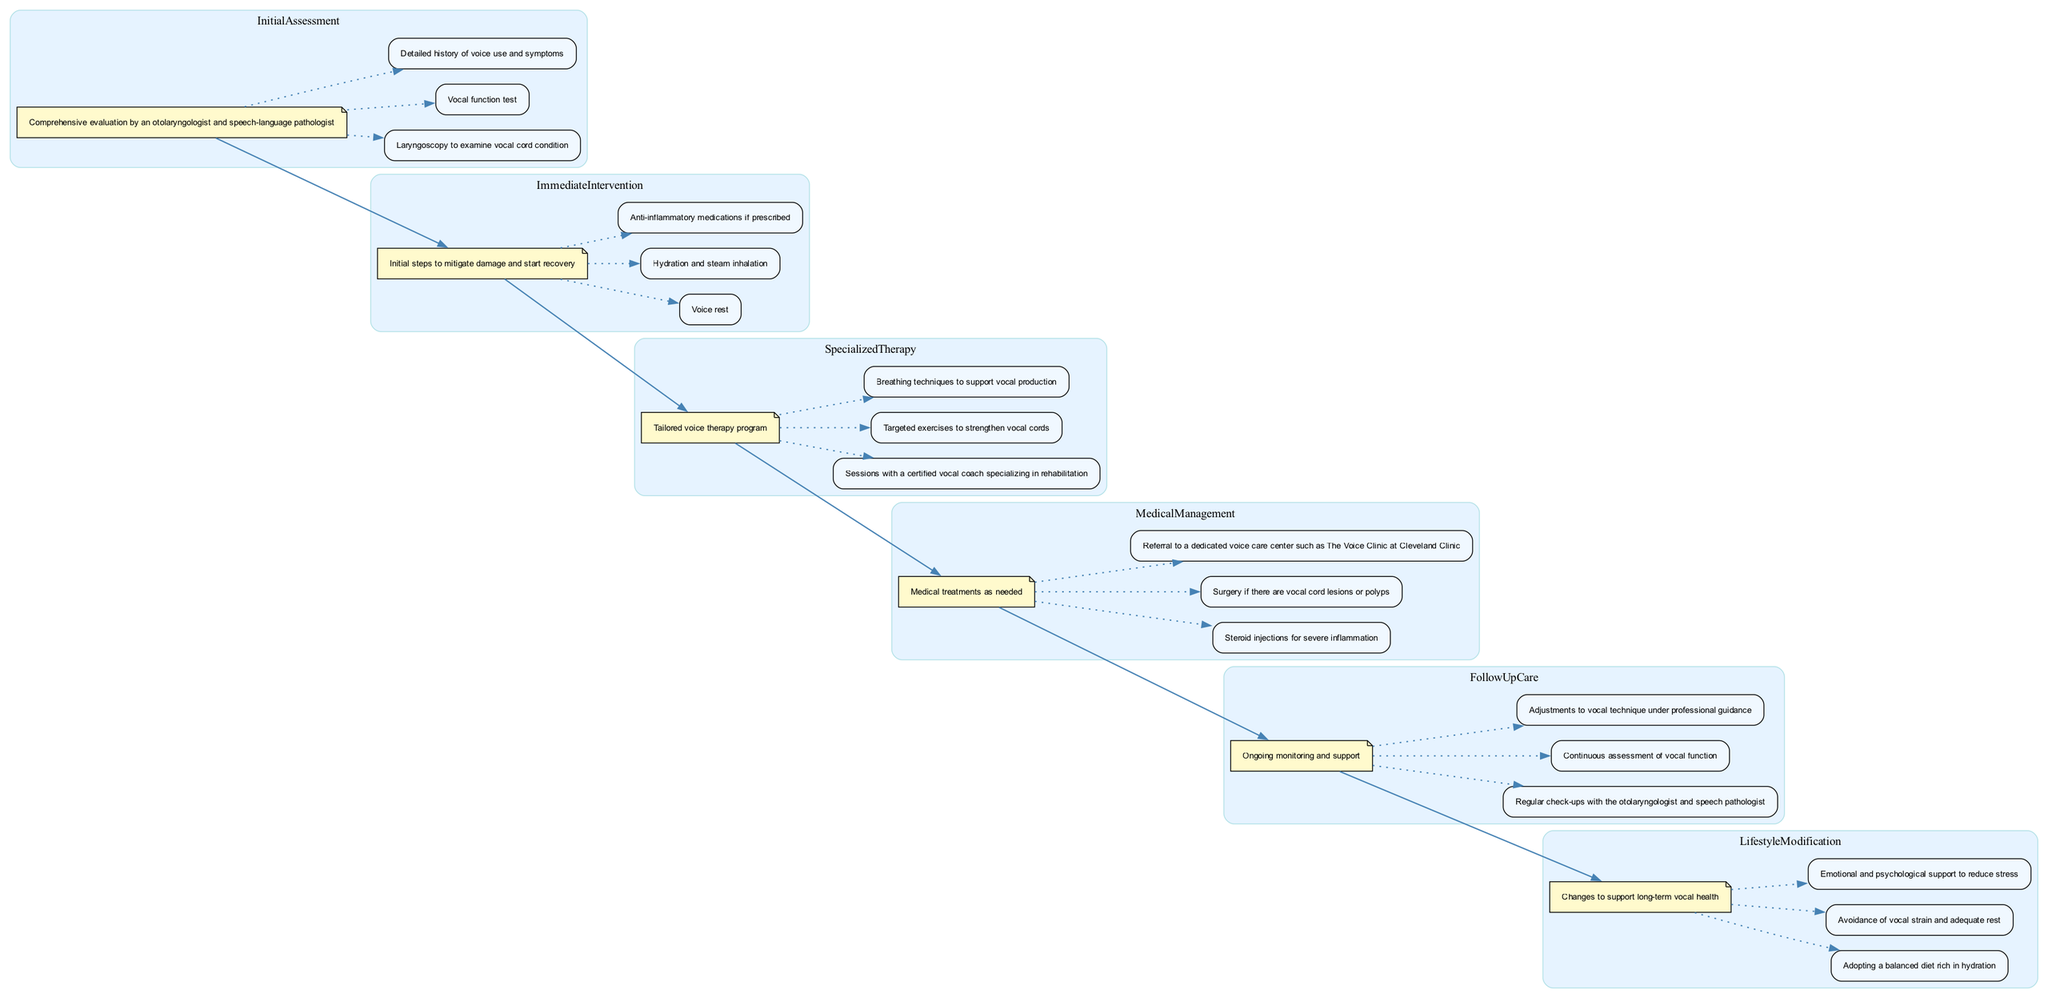What is the first stage of the pathway? The first stage is labeled "Initial Assessment" in the diagram, indicating it is the starting point of the vocal recovery process.
Answer: Initial Assessment How many key components are listed under Specialized Therapy? The diagram lists three key components under the "Specialized Therapy" stage, as evidenced by the boxes connected to its description note.
Answer: Three Which intervention focuses on voice rest? The "Immediate Intervention" stage explicitly highlights voice rest as one of its key components, making it the correct answer.
Answer: Immediate Intervention What is the main goal of Follow-Up Care? The description of the "Follow-Up Care" stage emphasizes ongoing monitoring and support, which is its primary purpose in the pathway.
Answer: Ongoing monitoring and support How many stages are there in the pathway? By counting the distinct stages labeled in the diagram, we observe that there are six stages represented throughout the pathway.
Answer: Six What medical treatment may be used for severe inflammation? The "Medical Management" stage mentions steroid injections as a specific treatment option for severe inflammation, indicating its relevance in the context.
Answer: Steroid injections Which lifestyle change is encouraged for long-term vocal health? The "Lifestyle Modification" section recommends adopting a balanced diet rich in hydration, reflecting its importance in vocal recovery.
Answer: Balanced diet rich in hydration What connects Immediate Intervention to Specialized Therapy? The edge linking the "Immediate Intervention" description node to the "Specialized Therapy" description node represents the flow from one stage to the next in the clinical pathway.
Answer: Flow from Immediate Intervention to Specialized Therapy What is the role of a certified vocal coach in the pathway? Within the "Specialized Therapy" stage, it specifies that a certified vocal coach specializing in rehabilitation is essential for guiding tailored voice therapy, demonstrating their role.
Answer: Tailored voice therapy guidance 